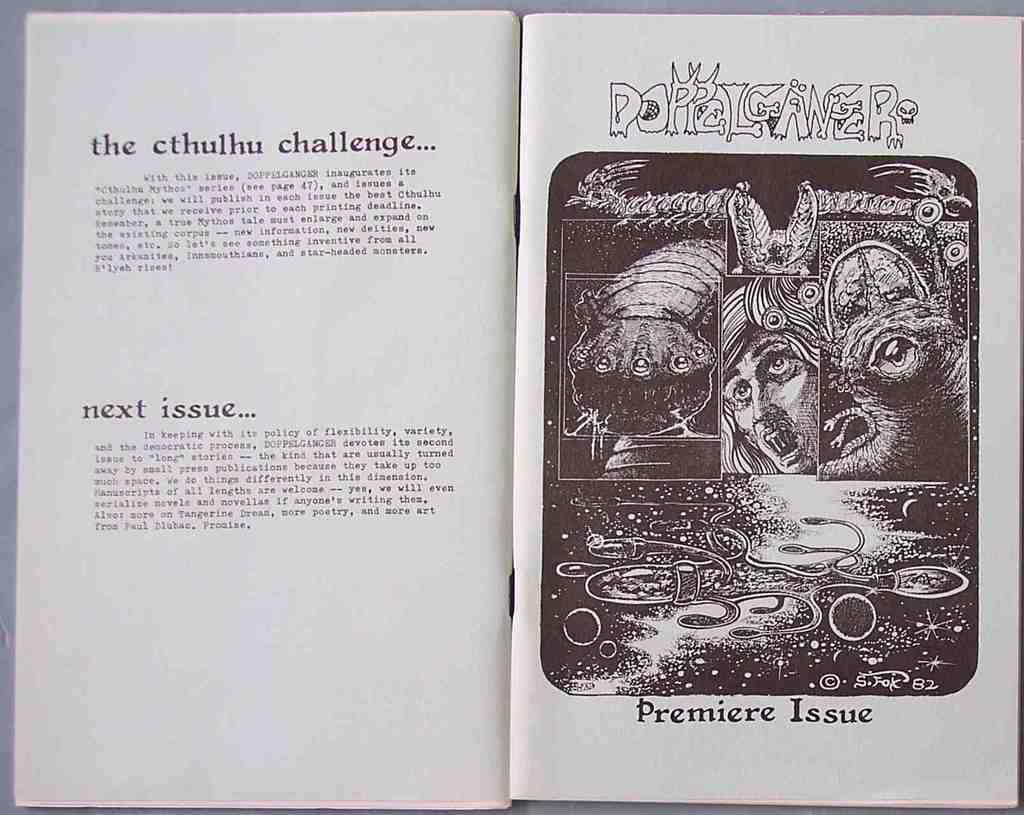<image>
Present a compact description of the photo's key features. The book shown is advertising the Premier Issue. 